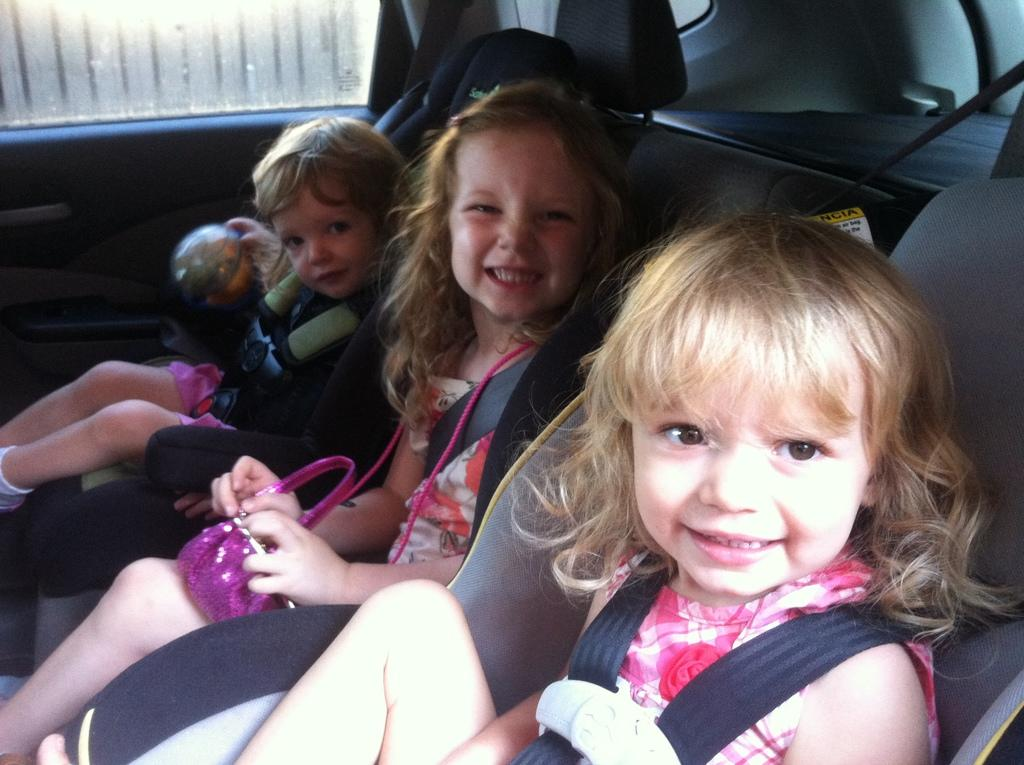How many people are in the vehicle in the image? There are three persons sitting in the vehicle. What is one person holding in the image? One person is holding a bag. What type of window can be seen in the vehicle? There is a glass window visible in the image. What type of egg is visible on the chain in the image? There is no egg or chain present in the image. 